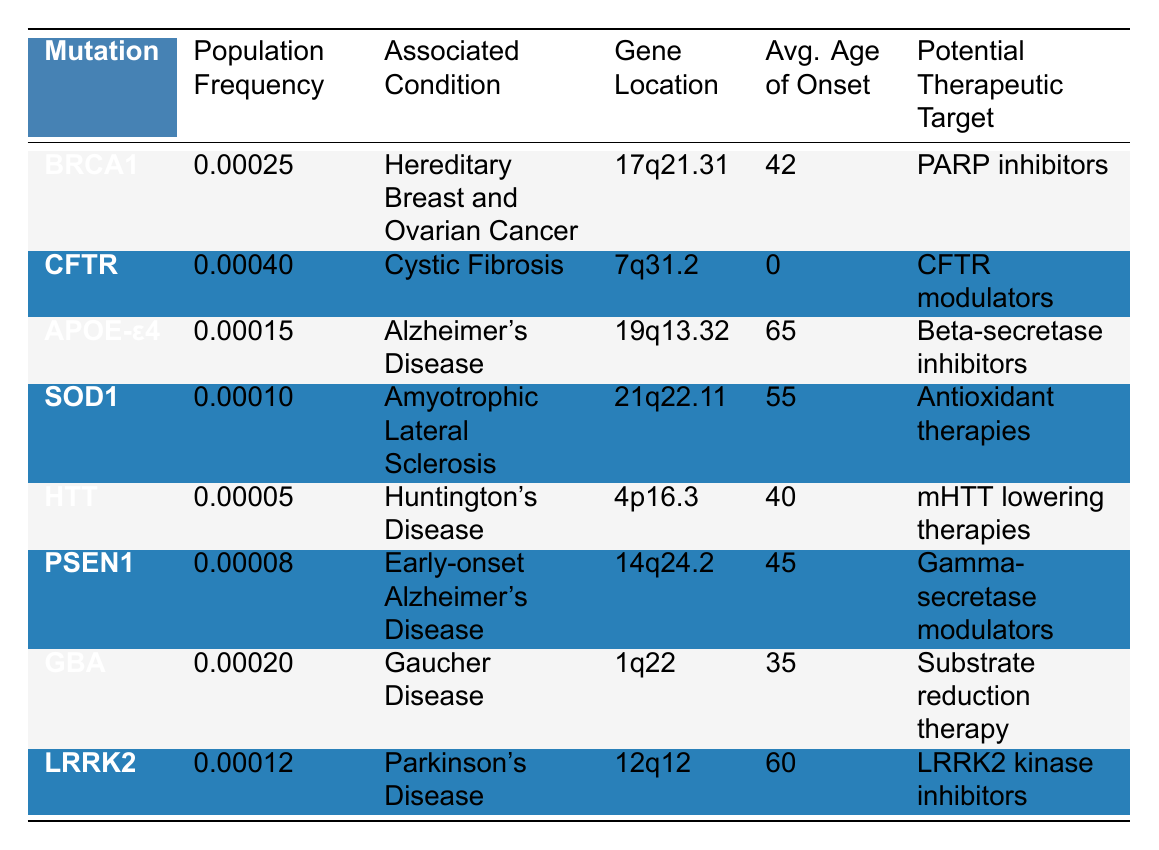What is the population frequency of the BRCA1 mutation? The table shows that the population frequency for the BRCA1 mutation is listed in the second column corresponding to BRCA1, which is 0.00025.
Answer: 0.00025 Which mutation is associated with Alzheimer's Disease? The third column of the table shows the associated conditions, where Alzheimer's Disease corresponds to the APOE-ε4 mutation in the first column.
Answer: APOE-ε4 What gene location corresponds to the LRRK2 mutation? The table lists gene locations in the fourth column. For the LRRK2 mutation, it states that the gene location is 12q12.
Answer: 12q12 What is the average age of onset for individuals with the GBA mutation? The average age of onset for the GBA mutation can be found in the fifth column, which indicates that it is 35 years old.
Answer: 35 Is the population frequency of the CFTR mutation higher than that of the SOD1 mutation? Comparing the population frequencies in the second column, CFTR has a frequency of 0.00040, and SOD1's frequency is 0.00010, which means CFTR is indeed higher.
Answer: Yes Which mutation has the lowest population frequency and what is it? By reviewing the population frequencies in the second column, the mutation with the lowest frequency is HTT at 0.00005.
Answer: HTT, 0.00005 What is the average age of onset for mutations associated with conditions that start before age 40? The mutations associated with conditions that start before age 40 are GBA (35) and HTT (40). The average can be calculated: (35 + 40) / 2 = 37.5.
Answer: 37.5 What therapeutic target is associated with the mutation linked to Amyotrophic Lateral Sclerosis? The table matches the condition of Amyotrophic Lateral Sclerosis with the SOD1 mutation, which has the therapeutic target listed as Antioxidant therapies in the last column.
Answer: Antioxidant therapies How many mutations have an average age of onset greater than 50? By checking the fifth column, the mutations with ages greater than 50 are APOE-ε4 (65), SOD1 (55), and LRRK2 (60), totaling 3 mutations.
Answer: 3 Which two mutations have potential therapeutic targets that involve enzyme modulation? The potential therapeutic targets listed for CFTR is CFTR modulators, and for PSEN1, it is Gamma-secretase modulators, indicating both involve modulation of enzymes.
Answer: CFTR and PSEN1 